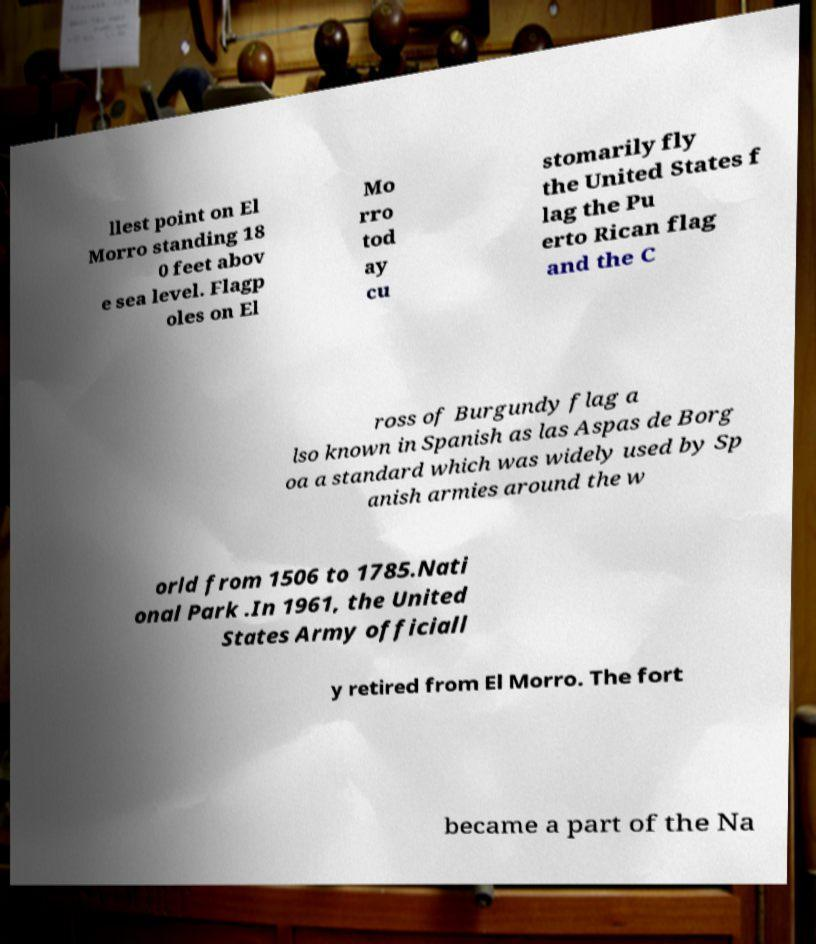Please identify and transcribe the text found in this image. llest point on El Morro standing 18 0 feet abov e sea level. Flagp oles on El Mo rro tod ay cu stomarily fly the United States f lag the Pu erto Rican flag and the C ross of Burgundy flag a lso known in Spanish as las Aspas de Borg oa a standard which was widely used by Sp anish armies around the w orld from 1506 to 1785.Nati onal Park .In 1961, the United States Army officiall y retired from El Morro. The fort became a part of the Na 